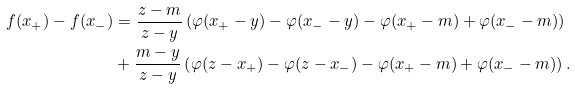<formula> <loc_0><loc_0><loc_500><loc_500>f ( x _ { + } ) - f ( x _ { - } ) & = \frac { z - m } { z - y } \left ( \varphi ( x _ { + } - y ) - \varphi ( x _ { - } - y ) - \varphi ( x _ { + } - m ) + \varphi ( x _ { - } - m ) \right ) \\ & + \frac { m - y } { z - y } \left ( \varphi ( z - x _ { + } ) - \varphi ( z - x _ { - } ) - \varphi ( x _ { + } - m ) + \varphi ( x _ { - } - m ) \right ) .</formula> 